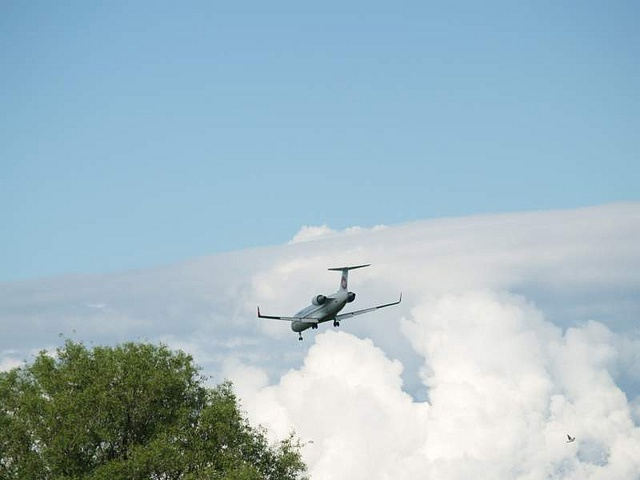Describe the objects in this image and their specific colors. I can see airplane in darkgray, gray, and black tones and bird in darkgray, gray, and black tones in this image. 